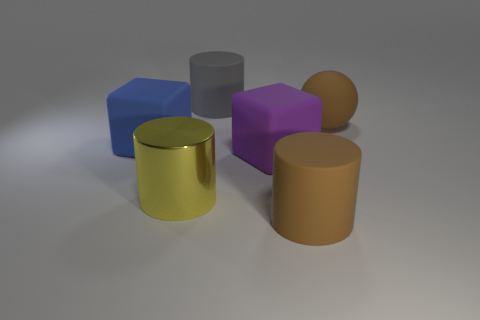Subtract all big rubber cylinders. How many cylinders are left? 1 Add 2 big brown spheres. How many objects exist? 8 Subtract all brown cylinders. How many cylinders are left? 2 Subtract 1 balls. How many balls are left? 0 Subtract all balls. How many objects are left? 5 Add 4 large gray matte things. How many large gray matte things exist? 5 Subtract 0 purple cylinders. How many objects are left? 6 Subtract all green blocks. Subtract all gray balls. How many blocks are left? 2 Subtract all brown blocks. How many green spheres are left? 0 Subtract all rubber cylinders. Subtract all rubber spheres. How many objects are left? 3 